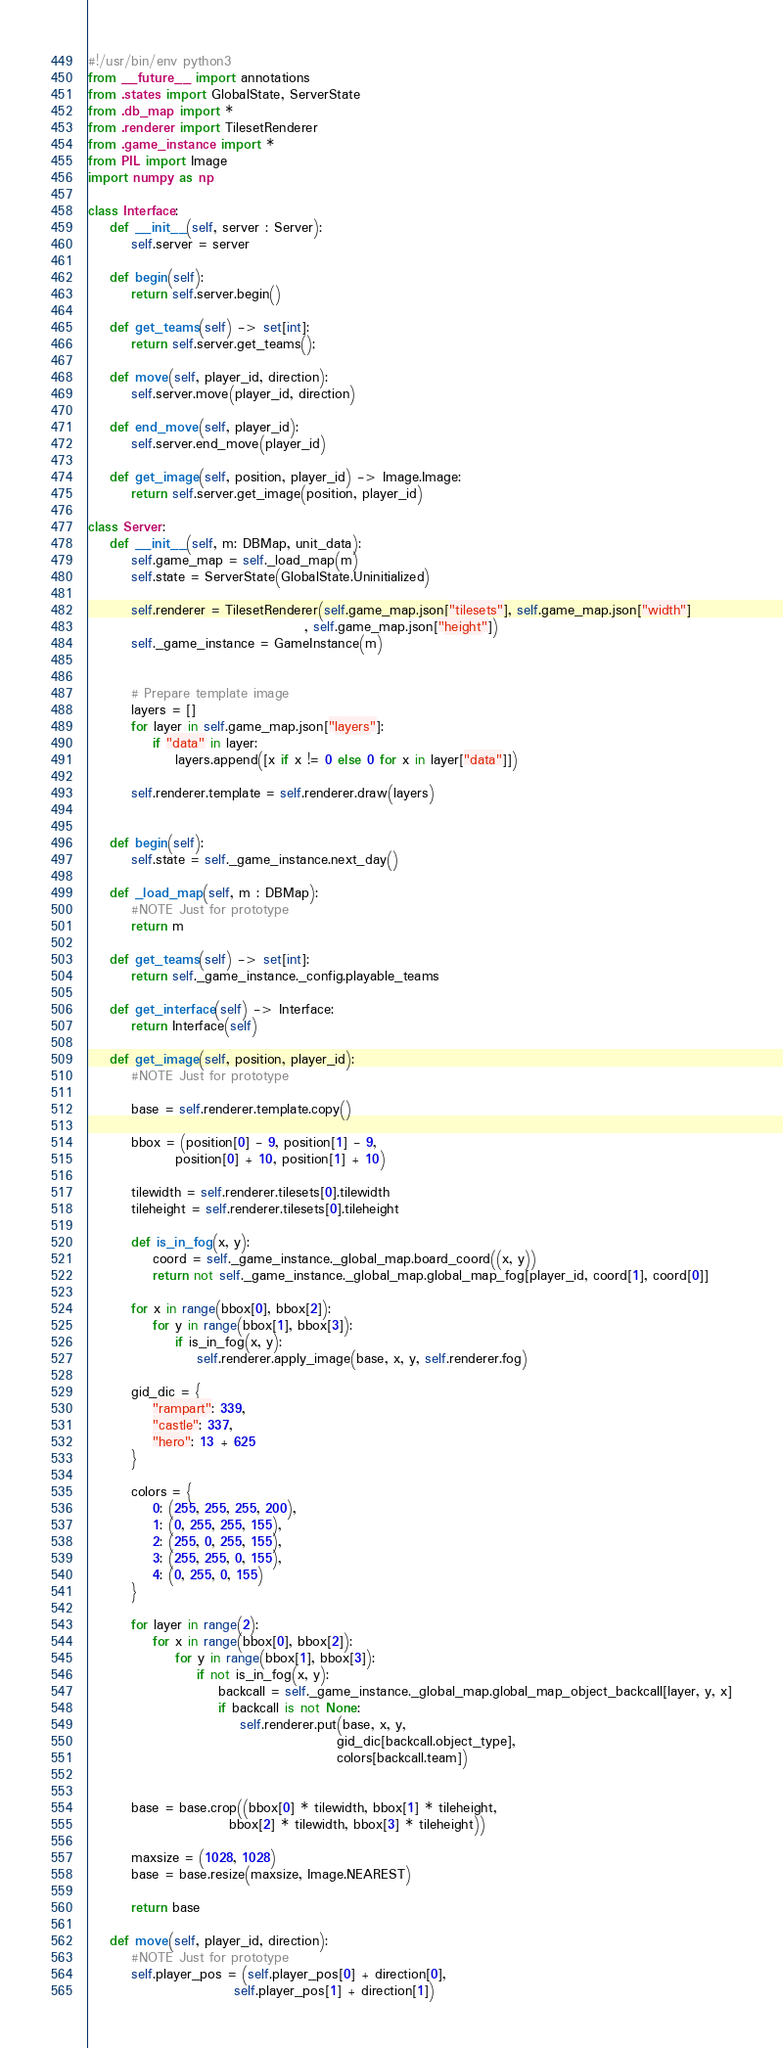Convert code to text. <code><loc_0><loc_0><loc_500><loc_500><_Python_>#!/usr/bin/env python3
from __future__ import annotations
from .states import GlobalState, ServerState
from .db_map import *
from .renderer import TilesetRenderer
from .game_instance import *
from PIL import Image
import numpy as np

class Interface:
    def __init__(self, server : Server):
        self.server = server

    def begin(self):
        return self.server.begin()

    def get_teams(self) -> set[int]:
        return self.server.get_teams();

    def move(self, player_id, direction):
        self.server.move(player_id, direction)

    def end_move(self, player_id):
        self.server.end_move(player_id)

    def get_image(self, position, player_id) -> Image.Image:
        return self.server.get_image(position, player_id)

class Server:
    def __init__(self, m: DBMap, unit_data):
        self.game_map = self._load_map(m)
        self.state = ServerState(GlobalState.Uninitialized)

        self.renderer = TilesetRenderer(self.game_map.json["tilesets"], self.game_map.json["width"]
                                        , self.game_map.json["height"])
        self._game_instance = GameInstance(m)


        # Prepare template image
        layers = []
        for layer in self.game_map.json["layers"]:
            if "data" in layer:
                layers.append([x if x != 0 else 0 for x in layer["data"]])

        self.renderer.template = self.renderer.draw(layers)


    def begin(self):
        self.state = self._game_instance.next_day()

    def _load_map(self, m : DBMap):
        #NOTE Just for prototype
        return m

    def get_teams(self) -> set[int]:
        return self._game_instance._config.playable_teams

    def get_interface(self) -> Interface:
        return Interface(self)

    def get_image(self, position, player_id):
        #NOTE Just for prototype

        base = self.renderer.template.copy()

        bbox = (position[0] - 9, position[1] - 9,
                position[0] + 10, position[1] + 10)

        tilewidth = self.renderer.tilesets[0].tilewidth
        tileheight = self.renderer.tilesets[0].tileheight

        def is_in_fog(x, y):
            coord = self._game_instance._global_map.board_coord((x, y))
            return not self._game_instance._global_map.global_map_fog[player_id, coord[1], coord[0]]

        for x in range(bbox[0], bbox[2]):
            for y in range(bbox[1], bbox[3]):
                if is_in_fog(x, y):
                    self.renderer.apply_image(base, x, y, self.renderer.fog)

        gid_dic = {
            "rampart": 339,
            "castle": 337,
            "hero": 13 + 625
        }

        colors = {
            0: (255, 255, 255, 200),
            1: (0, 255, 255, 155),
            2: (255, 0, 255, 155),
            3: (255, 255, 0, 155),
            4: (0, 255, 0, 155)
        }

        for layer in range(2):
            for x in range(bbox[0], bbox[2]):
                for y in range(bbox[1], bbox[3]):
                    if not is_in_fog(x, y):
                        backcall = self._game_instance._global_map.global_map_object_backcall[layer, y, x]
                        if backcall is not None:
                            self.renderer.put(base, x, y,
                                              gid_dic[backcall.object_type],
                                              colors[backcall.team])


        base = base.crop((bbox[0] * tilewidth, bbox[1] * tileheight,
                          bbox[2] * tilewidth, bbox[3] * tileheight))

        maxsize = (1028, 1028)
        base = base.resize(maxsize, Image.NEAREST)

        return base

    def move(self, player_id, direction):
        #NOTE Just for prototype
        self.player_pos = (self.player_pos[0] + direction[0],
                           self.player_pos[1] + direction[1])
</code> 